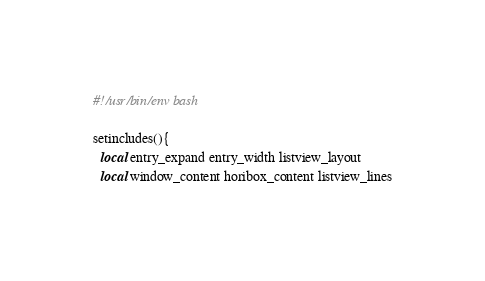<code> <loc_0><loc_0><loc_500><loc_500><_Bash_>#!/usr/bin/env bash

setincludes(){
  local entry_expand entry_width listview_layout 
  local window_content horibox_content listview_lines
</code> 